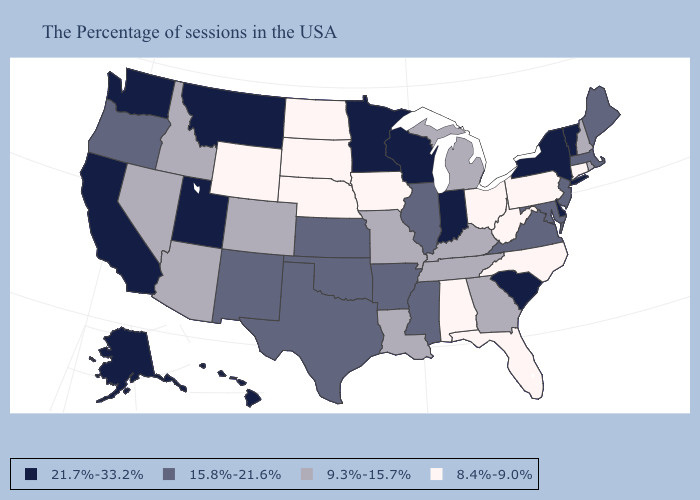Name the states that have a value in the range 21.7%-33.2%?
Concise answer only. Vermont, New York, Delaware, South Carolina, Indiana, Wisconsin, Minnesota, Utah, Montana, California, Washington, Alaska, Hawaii. Name the states that have a value in the range 21.7%-33.2%?
Concise answer only. Vermont, New York, Delaware, South Carolina, Indiana, Wisconsin, Minnesota, Utah, Montana, California, Washington, Alaska, Hawaii. Name the states that have a value in the range 9.3%-15.7%?
Answer briefly. Rhode Island, New Hampshire, Georgia, Michigan, Kentucky, Tennessee, Louisiana, Missouri, Colorado, Arizona, Idaho, Nevada. Does the map have missing data?
Answer briefly. No. Does California have the highest value in the USA?
Quick response, please. Yes. What is the value of Wyoming?
Short answer required. 8.4%-9.0%. What is the lowest value in the South?
Keep it brief. 8.4%-9.0%. What is the value of Rhode Island?
Write a very short answer. 9.3%-15.7%. Among the states that border Kansas , does Colorado have the highest value?
Quick response, please. No. Does Nevada have the lowest value in the USA?
Short answer required. No. Name the states that have a value in the range 8.4%-9.0%?
Concise answer only. Connecticut, Pennsylvania, North Carolina, West Virginia, Ohio, Florida, Alabama, Iowa, Nebraska, South Dakota, North Dakota, Wyoming. Name the states that have a value in the range 9.3%-15.7%?
Answer briefly. Rhode Island, New Hampshire, Georgia, Michigan, Kentucky, Tennessee, Louisiana, Missouri, Colorado, Arizona, Idaho, Nevada. Does the map have missing data?
Write a very short answer. No. Among the states that border New Mexico , which have the lowest value?
Concise answer only. Colorado, Arizona. Does Tennessee have the same value as Louisiana?
Concise answer only. Yes. 